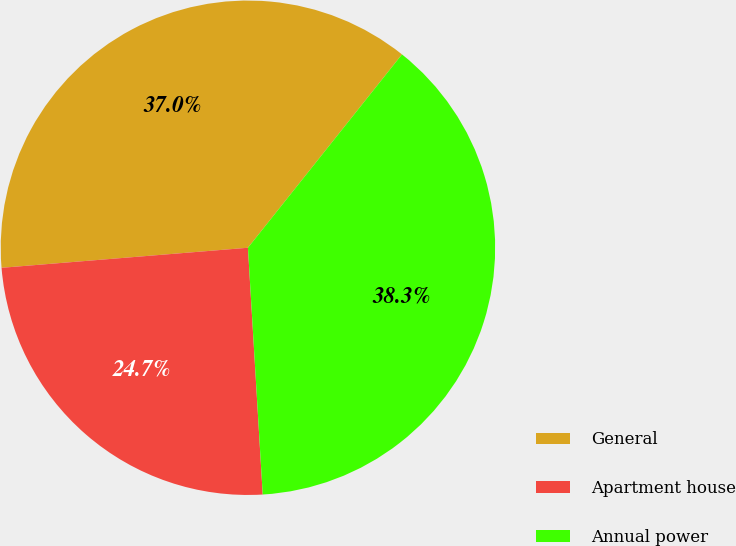Convert chart. <chart><loc_0><loc_0><loc_500><loc_500><pie_chart><fcel>General<fcel>Apartment house<fcel>Annual power<nl><fcel>37.0%<fcel>24.66%<fcel>38.34%<nl></chart> 